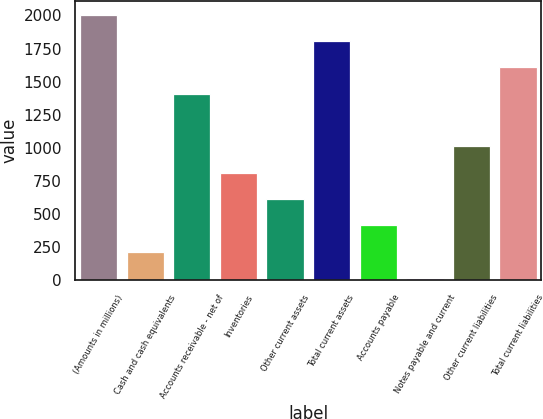Convert chart to OTSL. <chart><loc_0><loc_0><loc_500><loc_500><bar_chart><fcel>(Amounts in millions)<fcel>Cash and cash equivalents<fcel>Accounts receivable - net of<fcel>Inventories<fcel>Other current assets<fcel>Total current assets<fcel>Accounts payable<fcel>Notes payable and current<fcel>Other current liabilities<fcel>Total current liabilities<nl><fcel>2007<fcel>215.01<fcel>1409.67<fcel>812.34<fcel>613.23<fcel>1807.89<fcel>414.12<fcel>15.9<fcel>1011.45<fcel>1608.78<nl></chart> 